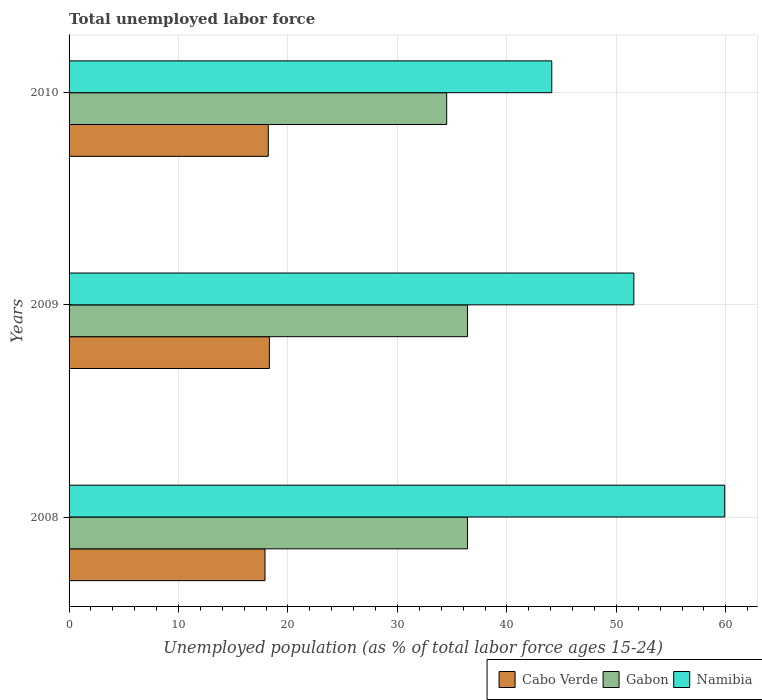How many groups of bars are there?
Provide a succinct answer. 3. Are the number of bars on each tick of the Y-axis equal?
Your answer should be compact. Yes. How many bars are there on the 2nd tick from the top?
Ensure brevity in your answer.  3. What is the label of the 2nd group of bars from the top?
Offer a very short reply. 2009. In how many cases, is the number of bars for a given year not equal to the number of legend labels?
Offer a very short reply. 0. What is the percentage of unemployed population in in Namibia in 2009?
Make the answer very short. 51.6. Across all years, what is the maximum percentage of unemployed population in in Namibia?
Offer a terse response. 59.9. Across all years, what is the minimum percentage of unemployed population in in Cabo Verde?
Make the answer very short. 17.9. In which year was the percentage of unemployed population in in Cabo Verde minimum?
Provide a short and direct response. 2008. What is the total percentage of unemployed population in in Namibia in the graph?
Your answer should be very brief. 155.6. What is the difference between the percentage of unemployed population in in Cabo Verde in 2008 and that in 2010?
Your answer should be very brief. -0.3. What is the difference between the percentage of unemployed population in in Namibia in 2009 and the percentage of unemployed population in in Cabo Verde in 2008?
Offer a terse response. 33.7. What is the average percentage of unemployed population in in Namibia per year?
Provide a succinct answer. 51.87. In the year 2009, what is the difference between the percentage of unemployed population in in Gabon and percentage of unemployed population in in Namibia?
Ensure brevity in your answer.  -15.2. In how many years, is the percentage of unemployed population in in Gabon greater than 42 %?
Offer a very short reply. 0. What is the ratio of the percentage of unemployed population in in Gabon in 2009 to that in 2010?
Your answer should be very brief. 1.06. Is the percentage of unemployed population in in Cabo Verde in 2008 less than that in 2009?
Provide a succinct answer. Yes. What is the difference between the highest and the second highest percentage of unemployed population in in Namibia?
Keep it short and to the point. 8.3. What is the difference between the highest and the lowest percentage of unemployed population in in Cabo Verde?
Provide a short and direct response. 0.4. In how many years, is the percentage of unemployed population in in Gabon greater than the average percentage of unemployed population in in Gabon taken over all years?
Offer a very short reply. 2. What does the 1st bar from the top in 2009 represents?
Provide a short and direct response. Namibia. What does the 3rd bar from the bottom in 2009 represents?
Your response must be concise. Namibia. Is it the case that in every year, the sum of the percentage of unemployed population in in Gabon and percentage of unemployed population in in Cabo Verde is greater than the percentage of unemployed population in in Namibia?
Keep it short and to the point. No. Are all the bars in the graph horizontal?
Provide a succinct answer. Yes. How many years are there in the graph?
Keep it short and to the point. 3. What is the difference between two consecutive major ticks on the X-axis?
Offer a very short reply. 10. Are the values on the major ticks of X-axis written in scientific E-notation?
Your response must be concise. No. Does the graph contain any zero values?
Provide a short and direct response. No. Does the graph contain grids?
Make the answer very short. Yes. How are the legend labels stacked?
Provide a short and direct response. Horizontal. What is the title of the graph?
Offer a terse response. Total unemployed labor force. Does "Hong Kong" appear as one of the legend labels in the graph?
Give a very brief answer. No. What is the label or title of the X-axis?
Provide a short and direct response. Unemployed population (as % of total labor force ages 15-24). What is the label or title of the Y-axis?
Ensure brevity in your answer.  Years. What is the Unemployed population (as % of total labor force ages 15-24) in Cabo Verde in 2008?
Keep it short and to the point. 17.9. What is the Unemployed population (as % of total labor force ages 15-24) in Gabon in 2008?
Your response must be concise. 36.4. What is the Unemployed population (as % of total labor force ages 15-24) of Namibia in 2008?
Provide a short and direct response. 59.9. What is the Unemployed population (as % of total labor force ages 15-24) in Cabo Verde in 2009?
Offer a terse response. 18.3. What is the Unemployed population (as % of total labor force ages 15-24) in Gabon in 2009?
Offer a very short reply. 36.4. What is the Unemployed population (as % of total labor force ages 15-24) in Namibia in 2009?
Keep it short and to the point. 51.6. What is the Unemployed population (as % of total labor force ages 15-24) in Cabo Verde in 2010?
Provide a succinct answer. 18.2. What is the Unemployed population (as % of total labor force ages 15-24) of Gabon in 2010?
Provide a succinct answer. 34.5. What is the Unemployed population (as % of total labor force ages 15-24) of Namibia in 2010?
Make the answer very short. 44.1. Across all years, what is the maximum Unemployed population (as % of total labor force ages 15-24) of Cabo Verde?
Your response must be concise. 18.3. Across all years, what is the maximum Unemployed population (as % of total labor force ages 15-24) of Gabon?
Your response must be concise. 36.4. Across all years, what is the maximum Unemployed population (as % of total labor force ages 15-24) in Namibia?
Make the answer very short. 59.9. Across all years, what is the minimum Unemployed population (as % of total labor force ages 15-24) in Cabo Verde?
Keep it short and to the point. 17.9. Across all years, what is the minimum Unemployed population (as % of total labor force ages 15-24) of Gabon?
Your answer should be compact. 34.5. Across all years, what is the minimum Unemployed population (as % of total labor force ages 15-24) in Namibia?
Keep it short and to the point. 44.1. What is the total Unemployed population (as % of total labor force ages 15-24) in Cabo Verde in the graph?
Make the answer very short. 54.4. What is the total Unemployed population (as % of total labor force ages 15-24) in Gabon in the graph?
Make the answer very short. 107.3. What is the total Unemployed population (as % of total labor force ages 15-24) in Namibia in the graph?
Your response must be concise. 155.6. What is the difference between the Unemployed population (as % of total labor force ages 15-24) in Cabo Verde in 2008 and that in 2010?
Your answer should be very brief. -0.3. What is the difference between the Unemployed population (as % of total labor force ages 15-24) in Gabon in 2008 and that in 2010?
Your answer should be compact. 1.9. What is the difference between the Unemployed population (as % of total labor force ages 15-24) of Cabo Verde in 2009 and that in 2010?
Ensure brevity in your answer.  0.1. What is the difference between the Unemployed population (as % of total labor force ages 15-24) of Gabon in 2009 and that in 2010?
Your answer should be compact. 1.9. What is the difference between the Unemployed population (as % of total labor force ages 15-24) of Namibia in 2009 and that in 2010?
Provide a short and direct response. 7.5. What is the difference between the Unemployed population (as % of total labor force ages 15-24) of Cabo Verde in 2008 and the Unemployed population (as % of total labor force ages 15-24) of Gabon in 2009?
Your response must be concise. -18.5. What is the difference between the Unemployed population (as % of total labor force ages 15-24) of Cabo Verde in 2008 and the Unemployed population (as % of total labor force ages 15-24) of Namibia in 2009?
Provide a short and direct response. -33.7. What is the difference between the Unemployed population (as % of total labor force ages 15-24) of Gabon in 2008 and the Unemployed population (as % of total labor force ages 15-24) of Namibia in 2009?
Provide a short and direct response. -15.2. What is the difference between the Unemployed population (as % of total labor force ages 15-24) in Cabo Verde in 2008 and the Unemployed population (as % of total labor force ages 15-24) in Gabon in 2010?
Offer a terse response. -16.6. What is the difference between the Unemployed population (as % of total labor force ages 15-24) of Cabo Verde in 2008 and the Unemployed population (as % of total labor force ages 15-24) of Namibia in 2010?
Your answer should be very brief. -26.2. What is the difference between the Unemployed population (as % of total labor force ages 15-24) of Cabo Verde in 2009 and the Unemployed population (as % of total labor force ages 15-24) of Gabon in 2010?
Make the answer very short. -16.2. What is the difference between the Unemployed population (as % of total labor force ages 15-24) of Cabo Verde in 2009 and the Unemployed population (as % of total labor force ages 15-24) of Namibia in 2010?
Provide a succinct answer. -25.8. What is the difference between the Unemployed population (as % of total labor force ages 15-24) in Gabon in 2009 and the Unemployed population (as % of total labor force ages 15-24) in Namibia in 2010?
Keep it short and to the point. -7.7. What is the average Unemployed population (as % of total labor force ages 15-24) in Cabo Verde per year?
Keep it short and to the point. 18.13. What is the average Unemployed population (as % of total labor force ages 15-24) of Gabon per year?
Offer a terse response. 35.77. What is the average Unemployed population (as % of total labor force ages 15-24) in Namibia per year?
Provide a short and direct response. 51.87. In the year 2008, what is the difference between the Unemployed population (as % of total labor force ages 15-24) in Cabo Verde and Unemployed population (as % of total labor force ages 15-24) in Gabon?
Offer a very short reply. -18.5. In the year 2008, what is the difference between the Unemployed population (as % of total labor force ages 15-24) in Cabo Verde and Unemployed population (as % of total labor force ages 15-24) in Namibia?
Offer a very short reply. -42. In the year 2008, what is the difference between the Unemployed population (as % of total labor force ages 15-24) of Gabon and Unemployed population (as % of total labor force ages 15-24) of Namibia?
Keep it short and to the point. -23.5. In the year 2009, what is the difference between the Unemployed population (as % of total labor force ages 15-24) in Cabo Verde and Unemployed population (as % of total labor force ages 15-24) in Gabon?
Provide a succinct answer. -18.1. In the year 2009, what is the difference between the Unemployed population (as % of total labor force ages 15-24) of Cabo Verde and Unemployed population (as % of total labor force ages 15-24) of Namibia?
Give a very brief answer. -33.3. In the year 2009, what is the difference between the Unemployed population (as % of total labor force ages 15-24) of Gabon and Unemployed population (as % of total labor force ages 15-24) of Namibia?
Keep it short and to the point. -15.2. In the year 2010, what is the difference between the Unemployed population (as % of total labor force ages 15-24) in Cabo Verde and Unemployed population (as % of total labor force ages 15-24) in Gabon?
Provide a short and direct response. -16.3. In the year 2010, what is the difference between the Unemployed population (as % of total labor force ages 15-24) of Cabo Verde and Unemployed population (as % of total labor force ages 15-24) of Namibia?
Ensure brevity in your answer.  -25.9. In the year 2010, what is the difference between the Unemployed population (as % of total labor force ages 15-24) of Gabon and Unemployed population (as % of total labor force ages 15-24) of Namibia?
Make the answer very short. -9.6. What is the ratio of the Unemployed population (as % of total labor force ages 15-24) in Cabo Verde in 2008 to that in 2009?
Provide a succinct answer. 0.98. What is the ratio of the Unemployed population (as % of total labor force ages 15-24) of Namibia in 2008 to that in 2009?
Provide a succinct answer. 1.16. What is the ratio of the Unemployed population (as % of total labor force ages 15-24) of Cabo Verde in 2008 to that in 2010?
Offer a terse response. 0.98. What is the ratio of the Unemployed population (as % of total labor force ages 15-24) in Gabon in 2008 to that in 2010?
Keep it short and to the point. 1.06. What is the ratio of the Unemployed population (as % of total labor force ages 15-24) in Namibia in 2008 to that in 2010?
Provide a succinct answer. 1.36. What is the ratio of the Unemployed population (as % of total labor force ages 15-24) of Cabo Verde in 2009 to that in 2010?
Offer a terse response. 1.01. What is the ratio of the Unemployed population (as % of total labor force ages 15-24) of Gabon in 2009 to that in 2010?
Keep it short and to the point. 1.06. What is the ratio of the Unemployed population (as % of total labor force ages 15-24) in Namibia in 2009 to that in 2010?
Your answer should be very brief. 1.17. What is the difference between the highest and the second highest Unemployed population (as % of total labor force ages 15-24) of Gabon?
Ensure brevity in your answer.  0. What is the difference between the highest and the second highest Unemployed population (as % of total labor force ages 15-24) in Namibia?
Your answer should be compact. 8.3. What is the difference between the highest and the lowest Unemployed population (as % of total labor force ages 15-24) in Gabon?
Your answer should be compact. 1.9. 